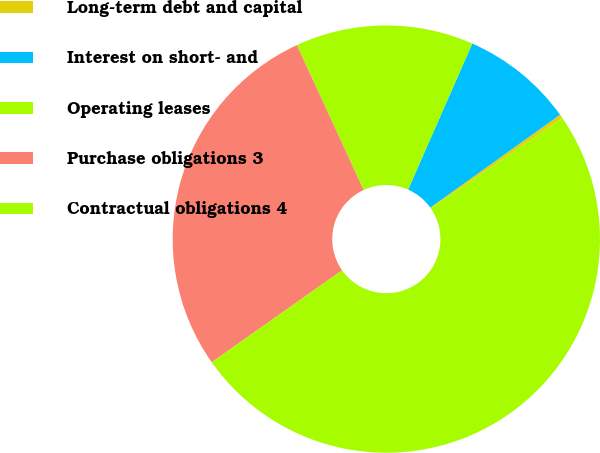Convert chart to OTSL. <chart><loc_0><loc_0><loc_500><loc_500><pie_chart><fcel>Long-term debt and capital<fcel>Interest on short- and<fcel>Operating leases<fcel>Purchase obligations 3<fcel>Contractual obligations 4<nl><fcel>0.3%<fcel>8.52%<fcel>13.47%<fcel>27.9%<fcel>49.81%<nl></chart> 